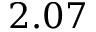Convert formula to latex. <formula><loc_0><loc_0><loc_500><loc_500>2 . 0 7</formula> 